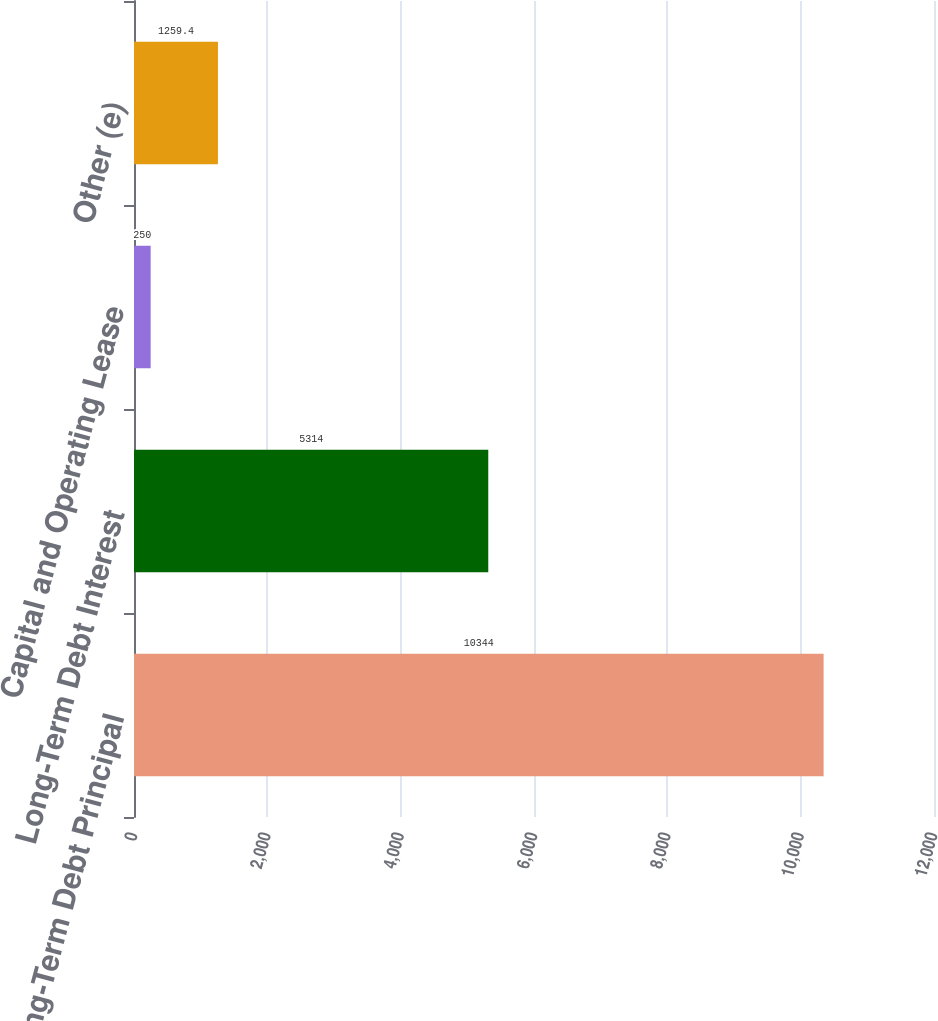Convert chart. <chart><loc_0><loc_0><loc_500><loc_500><bar_chart><fcel>Long-Term Debt Principal<fcel>Long-Term Debt Interest<fcel>Capital and Operating Lease<fcel>Other (e)<nl><fcel>10344<fcel>5314<fcel>250<fcel>1259.4<nl></chart> 